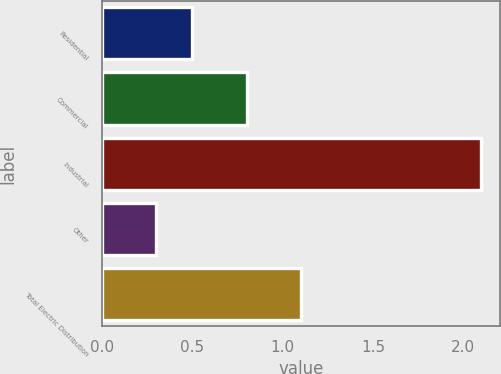<chart> <loc_0><loc_0><loc_500><loc_500><bar_chart><fcel>Residential<fcel>Commercial<fcel>Industrial<fcel>Other<fcel>Total Electric Distribution<nl><fcel>0.5<fcel>0.8<fcel>2.1<fcel>0.3<fcel>1.1<nl></chart> 